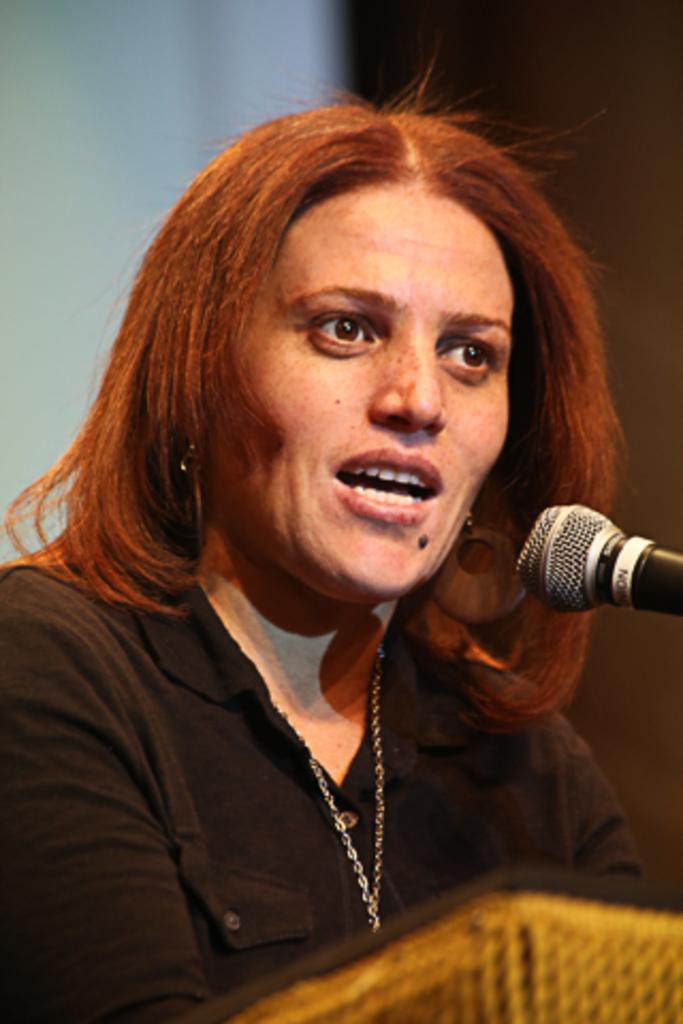Can you describe this image briefly? In this image there is a woman speaking in front of the mic and the background is blurry. In the front there is an object which is brown and black in colour. 